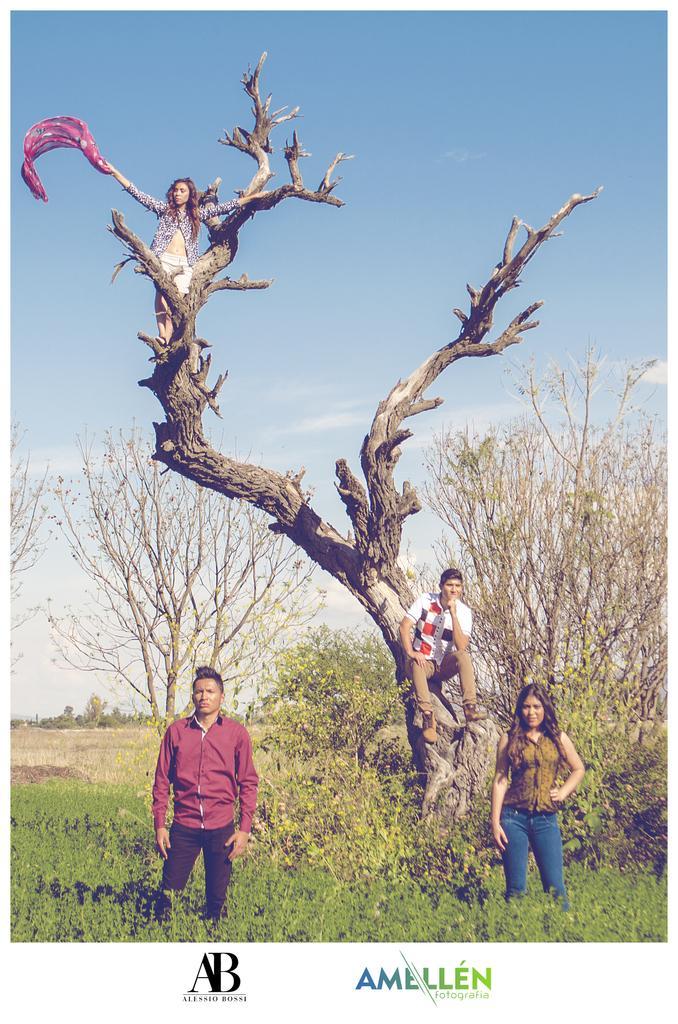How would you summarize this image in a sentence or two? In this picture I can observe four members. Two of them are standing on the land and two of them are on the tree. There are some plants on the ground. I can observe some text in this picture. In the background there is a sky with some clouds. 